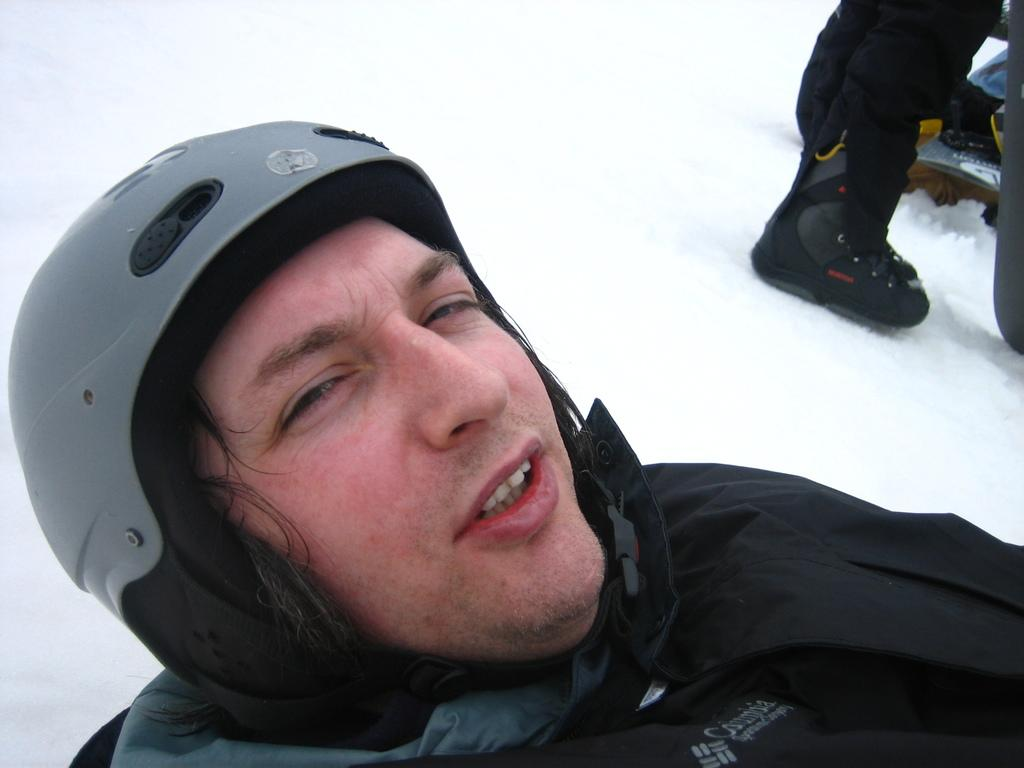What is the man in the image wearing? The man is wearing a black coat and helmet in the image. Where was the image taken? The image was taken outside. What is the weather like in the image? Snow is present in the image, indicating a cold or wintry environment. Are there any other people in the image? Yes, there is another man standing in the right corner of the image. What type of wire is being used to attack the man in the image? There is no wire or attack present in the image. 